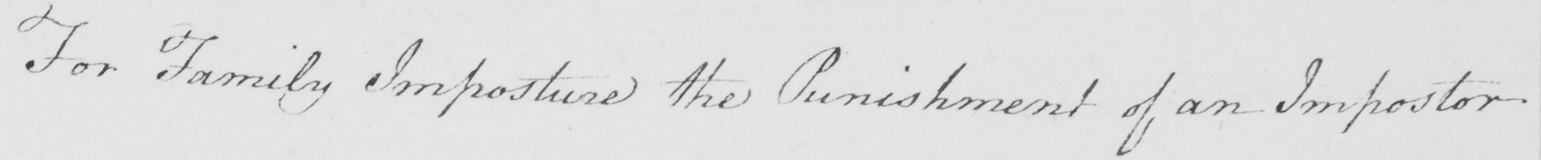Please transcribe the handwritten text in this image. For Family Imposture the Punishment of an Impostor 